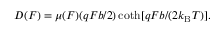Convert formula to latex. <formula><loc_0><loc_0><loc_500><loc_500>\begin{array} { r } { D ( F ) = \mu ( F ) ( q F b / 2 ) \coth [ q F b / ( 2 k _ { B } T ) ] . } \end{array}</formula> 